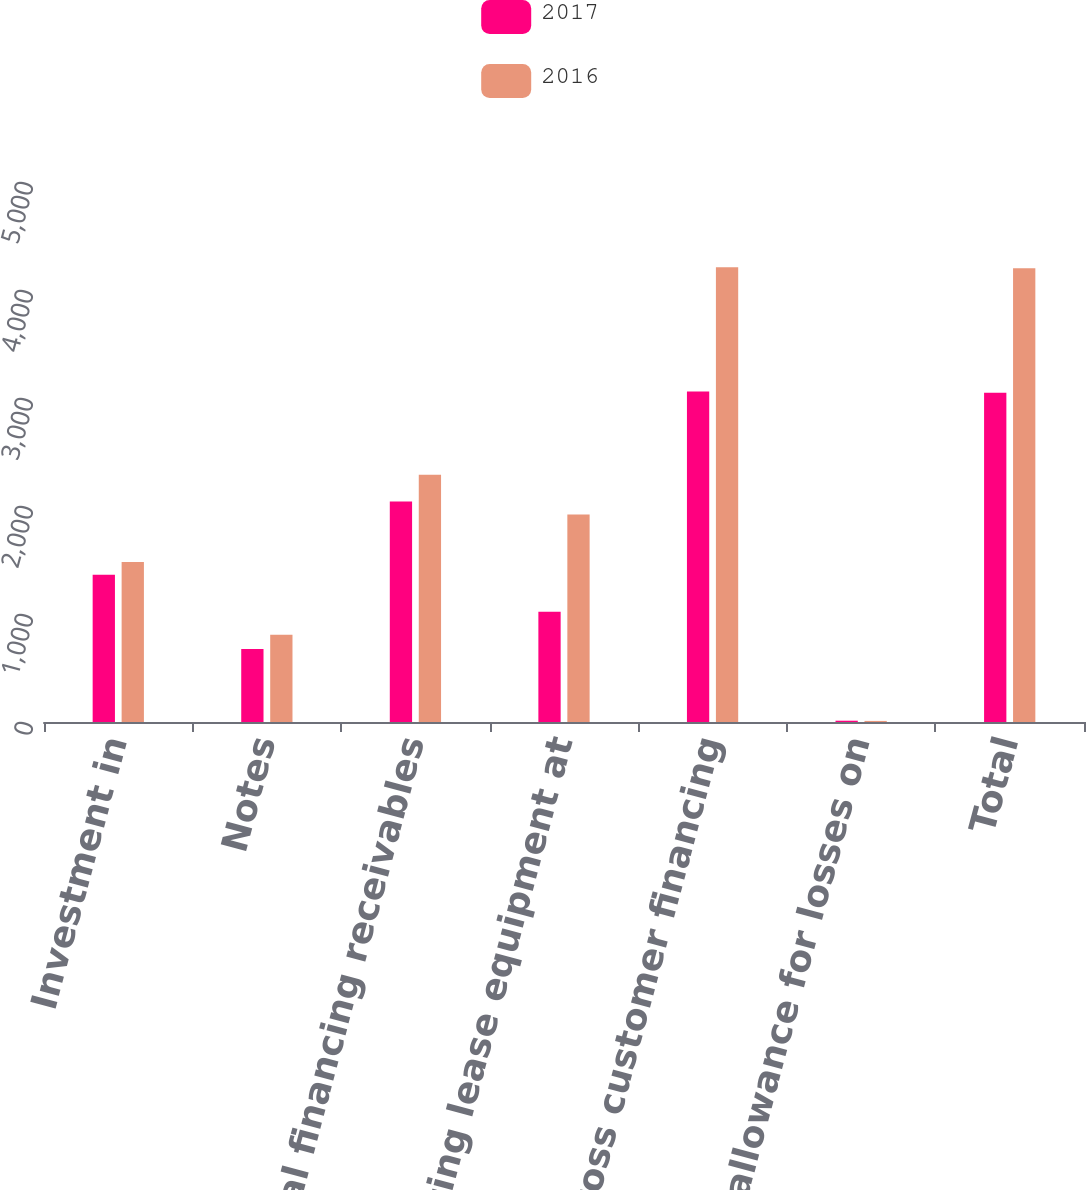Convert chart to OTSL. <chart><loc_0><loc_0><loc_500><loc_500><stacked_bar_chart><ecel><fcel>Investment in<fcel>Notes<fcel>Total financing receivables<fcel>Operating lease equipment at<fcel>Gross customer financing<fcel>Less allowance for losses on<fcel>Total<nl><fcel>2017<fcel>1364<fcel>677<fcel>2041<fcel>1020<fcel>3061<fcel>12<fcel>3049<nl><fcel>2016<fcel>1482<fcel>807<fcel>2289<fcel>1922<fcel>4211<fcel>10<fcel>4201<nl></chart> 